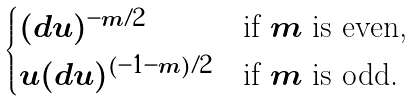<formula> <loc_0><loc_0><loc_500><loc_500>\begin{cases} ( d u ) ^ { - m / 2 } & \text {if $m$ is even,} \\ u ( d u ) ^ { ( - 1 - m ) / 2 } & \text {if $m$ is odd.} \end{cases}</formula> 